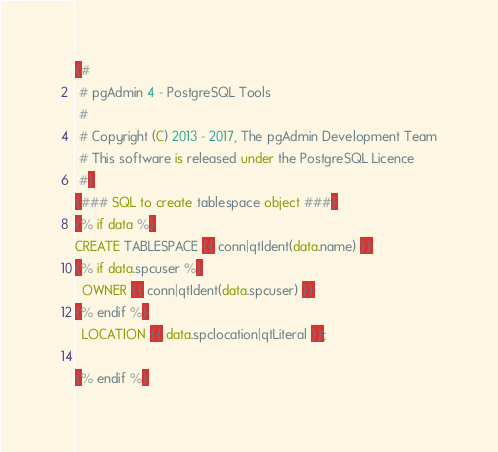Convert code to text. <code><loc_0><loc_0><loc_500><loc_500><_SQL_>{#
 # pgAdmin 4 - PostgreSQL Tools
 #
 # Copyright (C) 2013 - 2017, The pgAdmin Development Team
 # This software is released under the PostgreSQL Licence
 #}
{### SQL to create tablespace object ###}
{% if data %}
CREATE TABLESPACE {{ conn|qtIdent(data.name) }}
{% if data.spcuser %}
  OWNER {{ conn|qtIdent(data.spcuser) }}
{% endif %}
  LOCATION {{ data.spclocation|qtLiteral }};

{% endif %}</code> 